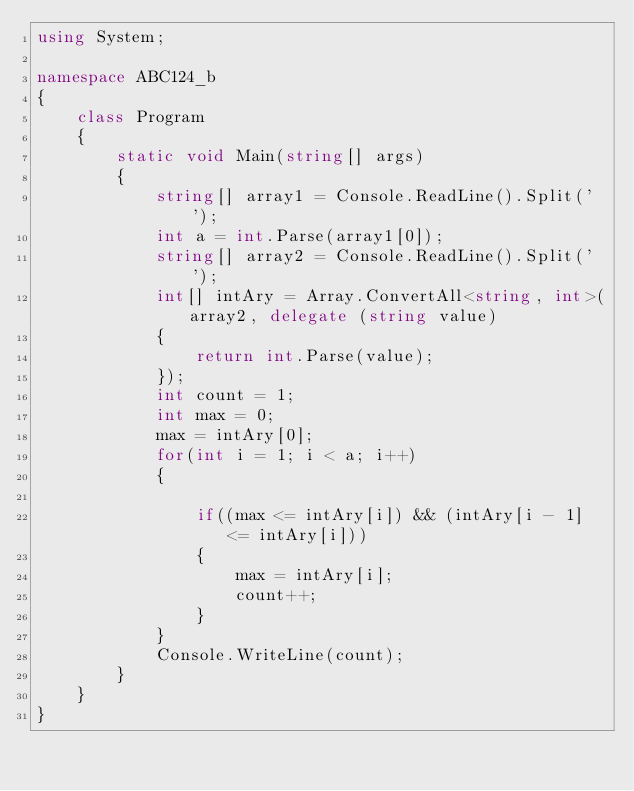<code> <loc_0><loc_0><loc_500><loc_500><_C#_>using System;

namespace ABC124_b
{
    class Program
    {
        static void Main(string[] args)
        {
            string[] array1 = Console.ReadLine().Split(' ');
            int a = int.Parse(array1[0]);
            string[] array2 = Console.ReadLine().Split(' ');
            int[] intAry = Array.ConvertAll<string, int>(array2, delegate (string value)
            {
                return int.Parse(value);
            });
            int count = 1;
            int max = 0;
            max = intAry[0];
            for(int i = 1; i < a; i++)
            {
                
                if((max <= intAry[i]) && (intAry[i - 1] <= intAry[i]))
                {
                    max = intAry[i];
                    count++;
                }
            }
            Console.WriteLine(count);
        }
    }
}
</code> 